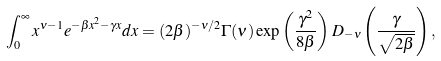Convert formula to latex. <formula><loc_0><loc_0><loc_500><loc_500>\int _ { 0 } ^ { \infty } x ^ { \nu - 1 } e ^ { - \beta x ^ { 2 } - \gamma x } d x = ( 2 \beta ) ^ { - \nu / 2 } \Gamma ( \nu ) \exp \left ( { \frac { \gamma ^ { 2 } } { 8 \beta } } \right ) D _ { - \nu } \left ( \frac { \gamma } { \sqrt { 2 \beta } } \right ) ,</formula> 